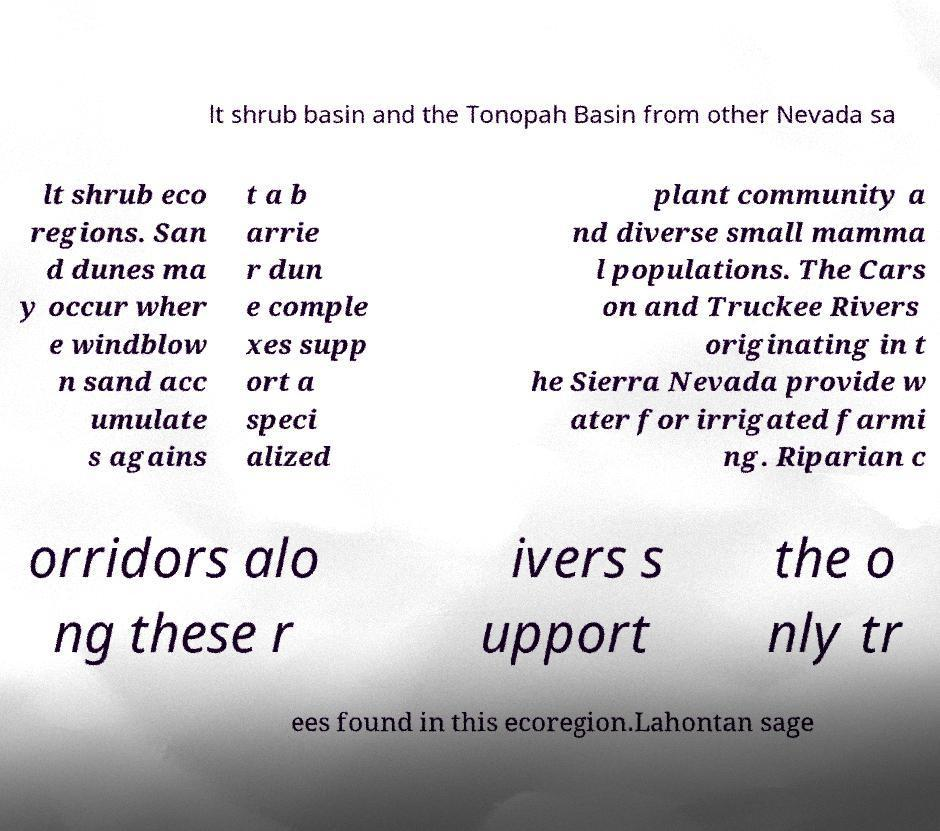Please identify and transcribe the text found in this image. lt shrub basin and the Tonopah Basin from other Nevada sa lt shrub eco regions. San d dunes ma y occur wher e windblow n sand acc umulate s agains t a b arrie r dun e comple xes supp ort a speci alized plant community a nd diverse small mamma l populations. The Cars on and Truckee Rivers originating in t he Sierra Nevada provide w ater for irrigated farmi ng. Riparian c orridors alo ng these r ivers s upport the o nly tr ees found in this ecoregion.Lahontan sage 